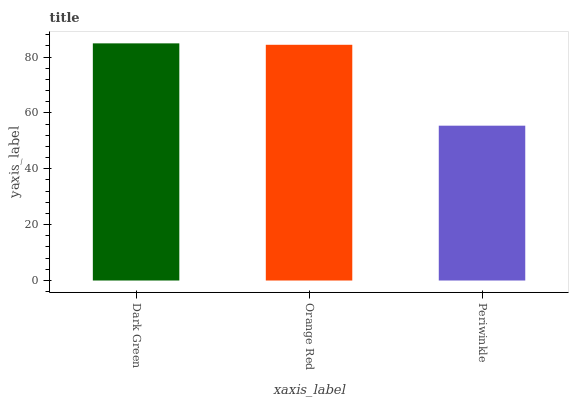Is Orange Red the minimum?
Answer yes or no. No. Is Orange Red the maximum?
Answer yes or no. No. Is Dark Green greater than Orange Red?
Answer yes or no. Yes. Is Orange Red less than Dark Green?
Answer yes or no. Yes. Is Orange Red greater than Dark Green?
Answer yes or no. No. Is Dark Green less than Orange Red?
Answer yes or no. No. Is Orange Red the high median?
Answer yes or no. Yes. Is Orange Red the low median?
Answer yes or no. Yes. Is Dark Green the high median?
Answer yes or no. No. Is Dark Green the low median?
Answer yes or no. No. 